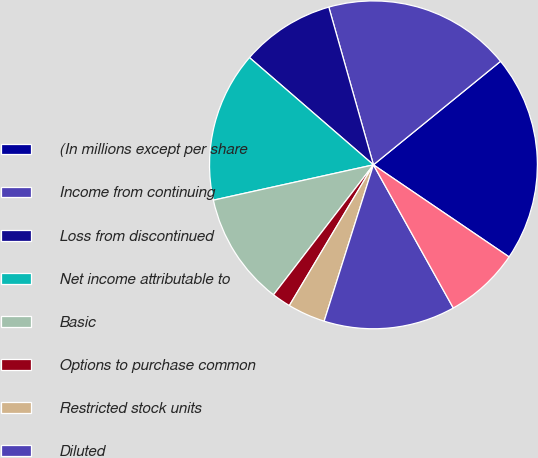Convert chart to OTSL. <chart><loc_0><loc_0><loc_500><loc_500><pie_chart><fcel>(In millions except per share<fcel>Income from continuing<fcel>Loss from discontinued<fcel>Net income attributable to<fcel>Basic<fcel>Options to purchase common<fcel>Restricted stock units<fcel>Diluted<fcel>Continuing operations<nl><fcel>20.37%<fcel>18.51%<fcel>9.26%<fcel>14.81%<fcel>11.11%<fcel>1.86%<fcel>3.71%<fcel>12.96%<fcel>7.41%<nl></chart> 